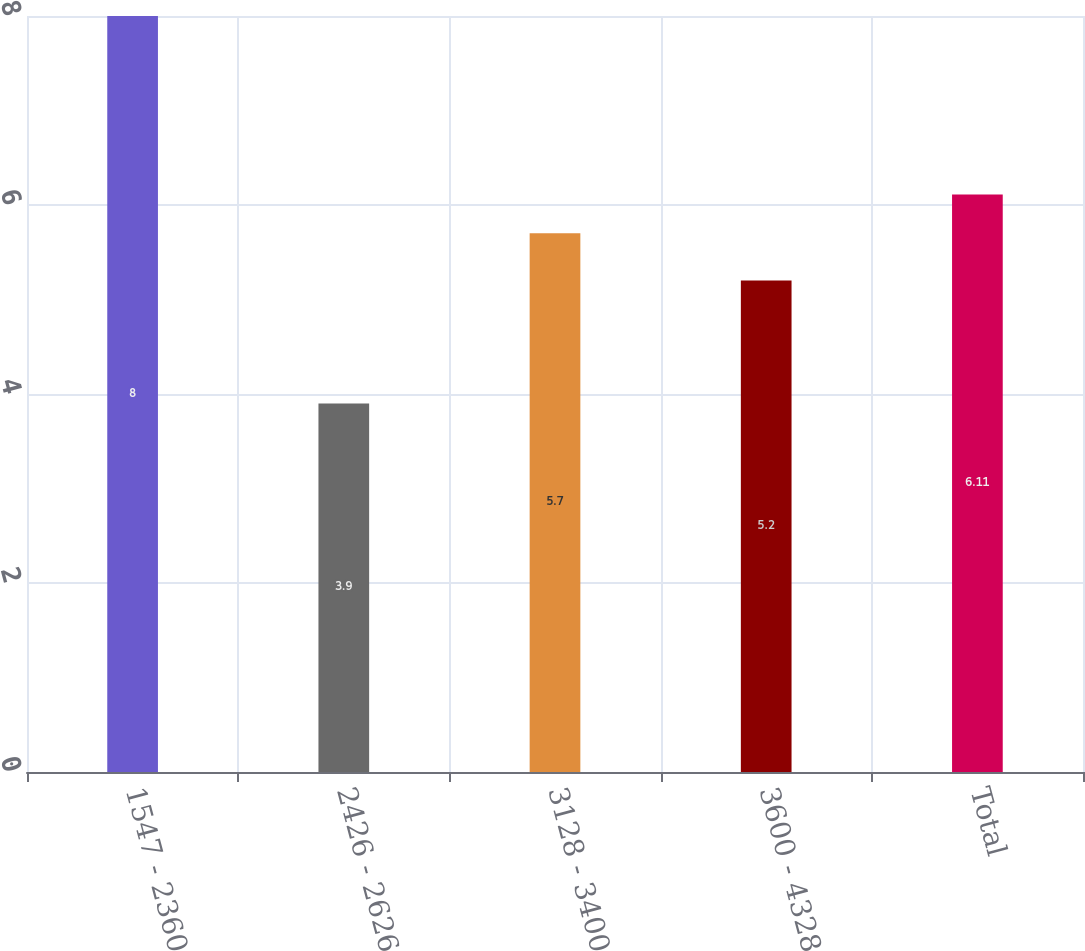<chart> <loc_0><loc_0><loc_500><loc_500><bar_chart><fcel>1547 - 2360<fcel>2426 - 2626<fcel>3128 - 3400<fcel>3600 - 4328<fcel>Total<nl><fcel>8<fcel>3.9<fcel>5.7<fcel>5.2<fcel>6.11<nl></chart> 